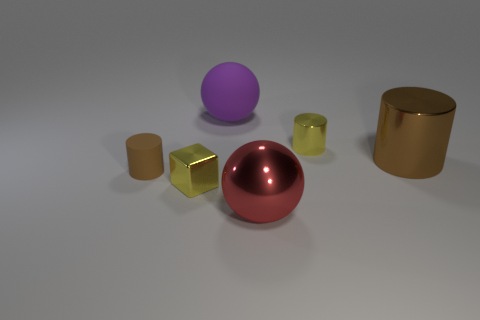Subtract all tiny matte cylinders. How many cylinders are left? 2 Subtract all cyan cubes. How many brown cylinders are left? 2 Add 1 blue cylinders. How many objects exist? 7 Subtract 1 cylinders. How many cylinders are left? 2 Subtract all balls. How many objects are left? 4 Add 6 yellow shiny cubes. How many yellow shiny cubes exist? 7 Subtract 0 red cylinders. How many objects are left? 6 Subtract all purple cylinders. Subtract all blue cubes. How many cylinders are left? 3 Subtract all red metal spheres. Subtract all big brown things. How many objects are left? 4 Add 4 large red things. How many large red things are left? 5 